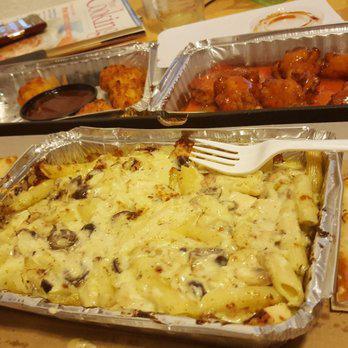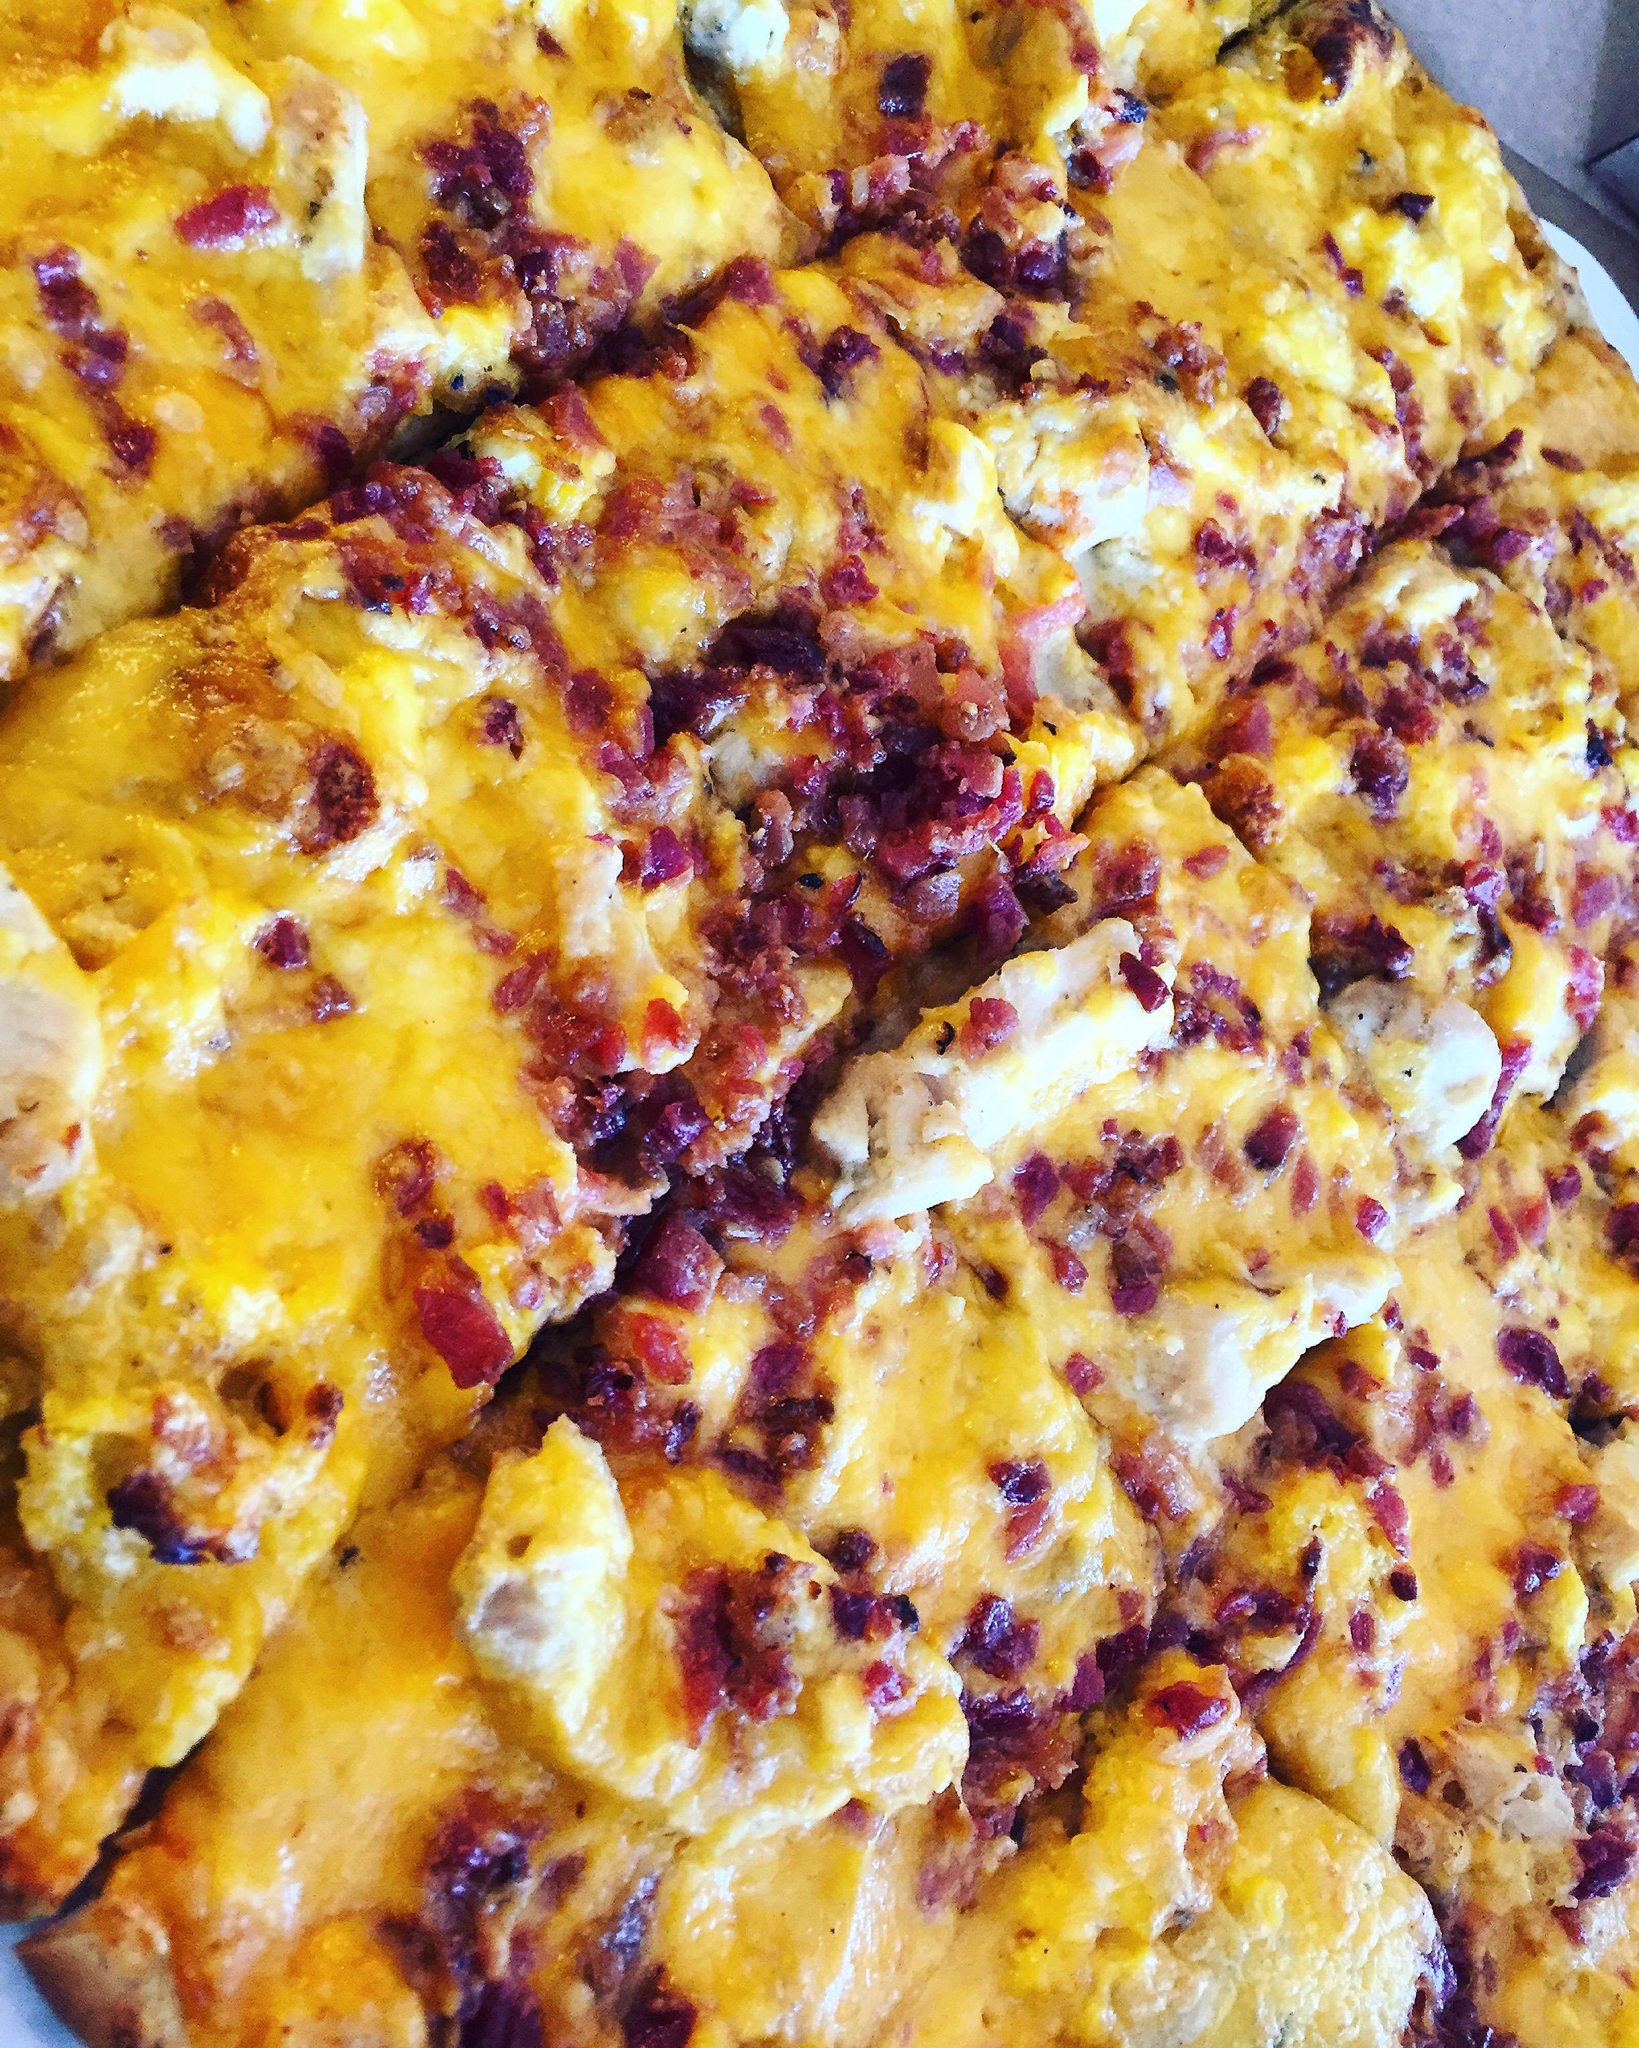The first image is the image on the left, the second image is the image on the right. Analyze the images presented: Is the assertion "The left image shows a rectangular metal tray containing something that is mostly yellow." valid? Answer yes or no. Yes. The first image is the image on the left, the second image is the image on the right. Examine the images to the left and right. Is the description "The left and right image contains the same number of full pizzas." accurate? Answer yes or no. No. 